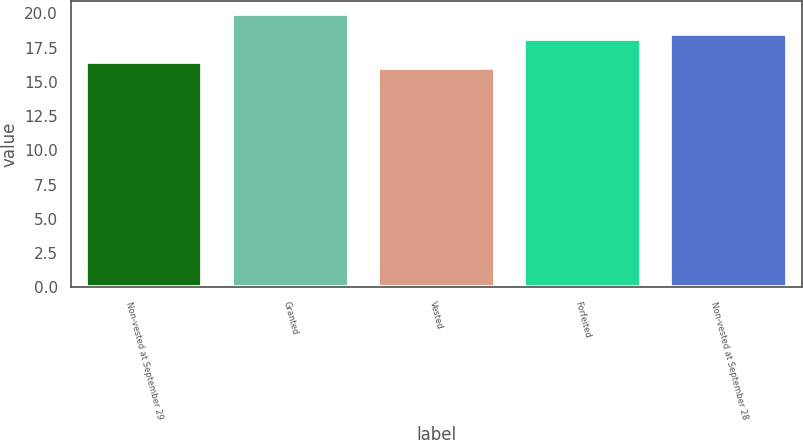<chart> <loc_0><loc_0><loc_500><loc_500><bar_chart><fcel>Non-vested at September 29<fcel>Granted<fcel>Vested<fcel>Forfeited<fcel>Non-vested at September 28<nl><fcel>16.45<fcel>19.94<fcel>15.98<fcel>18.11<fcel>18.51<nl></chart> 